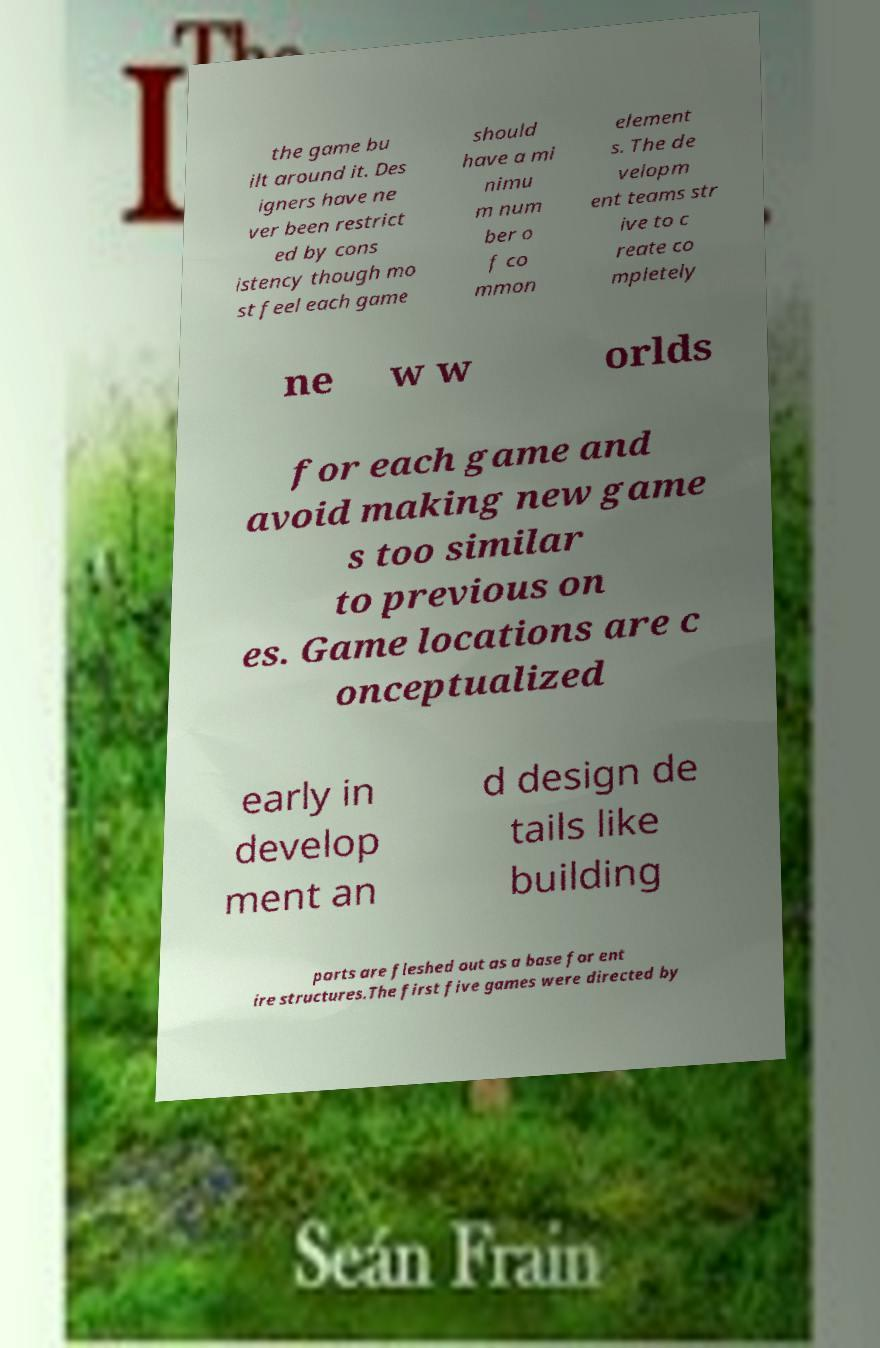Could you assist in decoding the text presented in this image and type it out clearly? the game bu ilt around it. Des igners have ne ver been restrict ed by cons istency though mo st feel each game should have a mi nimu m num ber o f co mmon element s. The de velopm ent teams str ive to c reate co mpletely ne w w orlds for each game and avoid making new game s too similar to previous on es. Game locations are c onceptualized early in develop ment an d design de tails like building parts are fleshed out as a base for ent ire structures.The first five games were directed by 